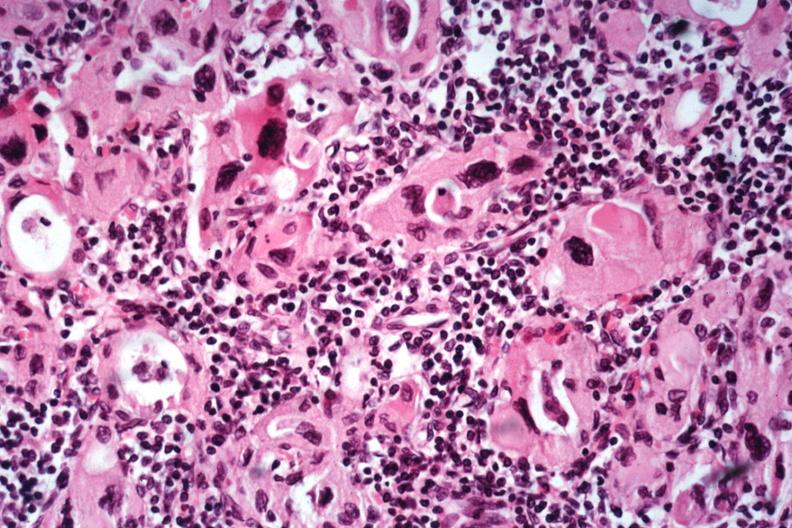does situs inversus show excellent example lymphocytes and hurthle like cells no recognizable thyroid tissue?
Answer the question using a single word or phrase. No 